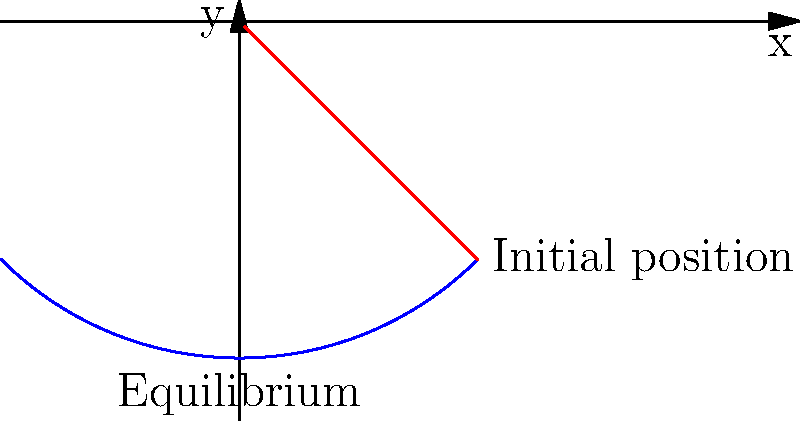In a platformer game, a character swings on a rope of length $L = 5$ meters, starting from an initial angle of $\theta_0 = \frac{\pi}{4}$ radians. Given that the acceleration due to gravity is $g = 9.8$ m/s², calculate the period of oscillation for the character's swing. How might this affect the timing of player inputs for optimal momentum in gameplay? To solve this problem and understand its impact on gameplay, let's follow these steps:

1) The period of a simple pendulum is given by the formula:

   $$T = 2\pi \sqrt{\frac{L}{g}}$$

   Where:
   $T$ is the period of oscillation
   $L$ is the length of the pendulum (rope)
   $g$ is the acceleration due to gravity

2) Substituting the given values:
   $L = 5$ m
   $g = 9.8$ m/s²

3) Calculate the period:

   $$T = 2\pi \sqrt{\frac{5}{9.8}} \approx 4.48 \text{ seconds}$$

4) Impact on gameplay:
   
   a) The period represents the time for one complete swing (back and forth). This means the character will reach the highest point on either side every 2.24 seconds (half the period).
   
   b) For optimal momentum, players should time their inputs (like jumps or releases) near these peak points of the swing, where potential energy is highest and is about to convert to kinetic energy.
   
   c) Game designers can use this information to:
      - Set the timing windows for special moves or momentum-based actions
      - Design levels that require precise timing based on the swing mechanics
      - Create challenges that involve syncing multiple swinging elements

   d) The natural frequency of the swing ($f = \frac{1}{T} \approx 0.22$ Hz) could be used to sync background music or sound effects with the gameplay, enhancing immersion.

   e) Developers might consider adding a visual or audio cue that matches this frequency to help players internalize the rhythm of the swing for more intuitive gameplay.
Answer: Period: 4.48 seconds. Affects input timing for momentum-based actions at swing peaks (every 2.24 seconds). 